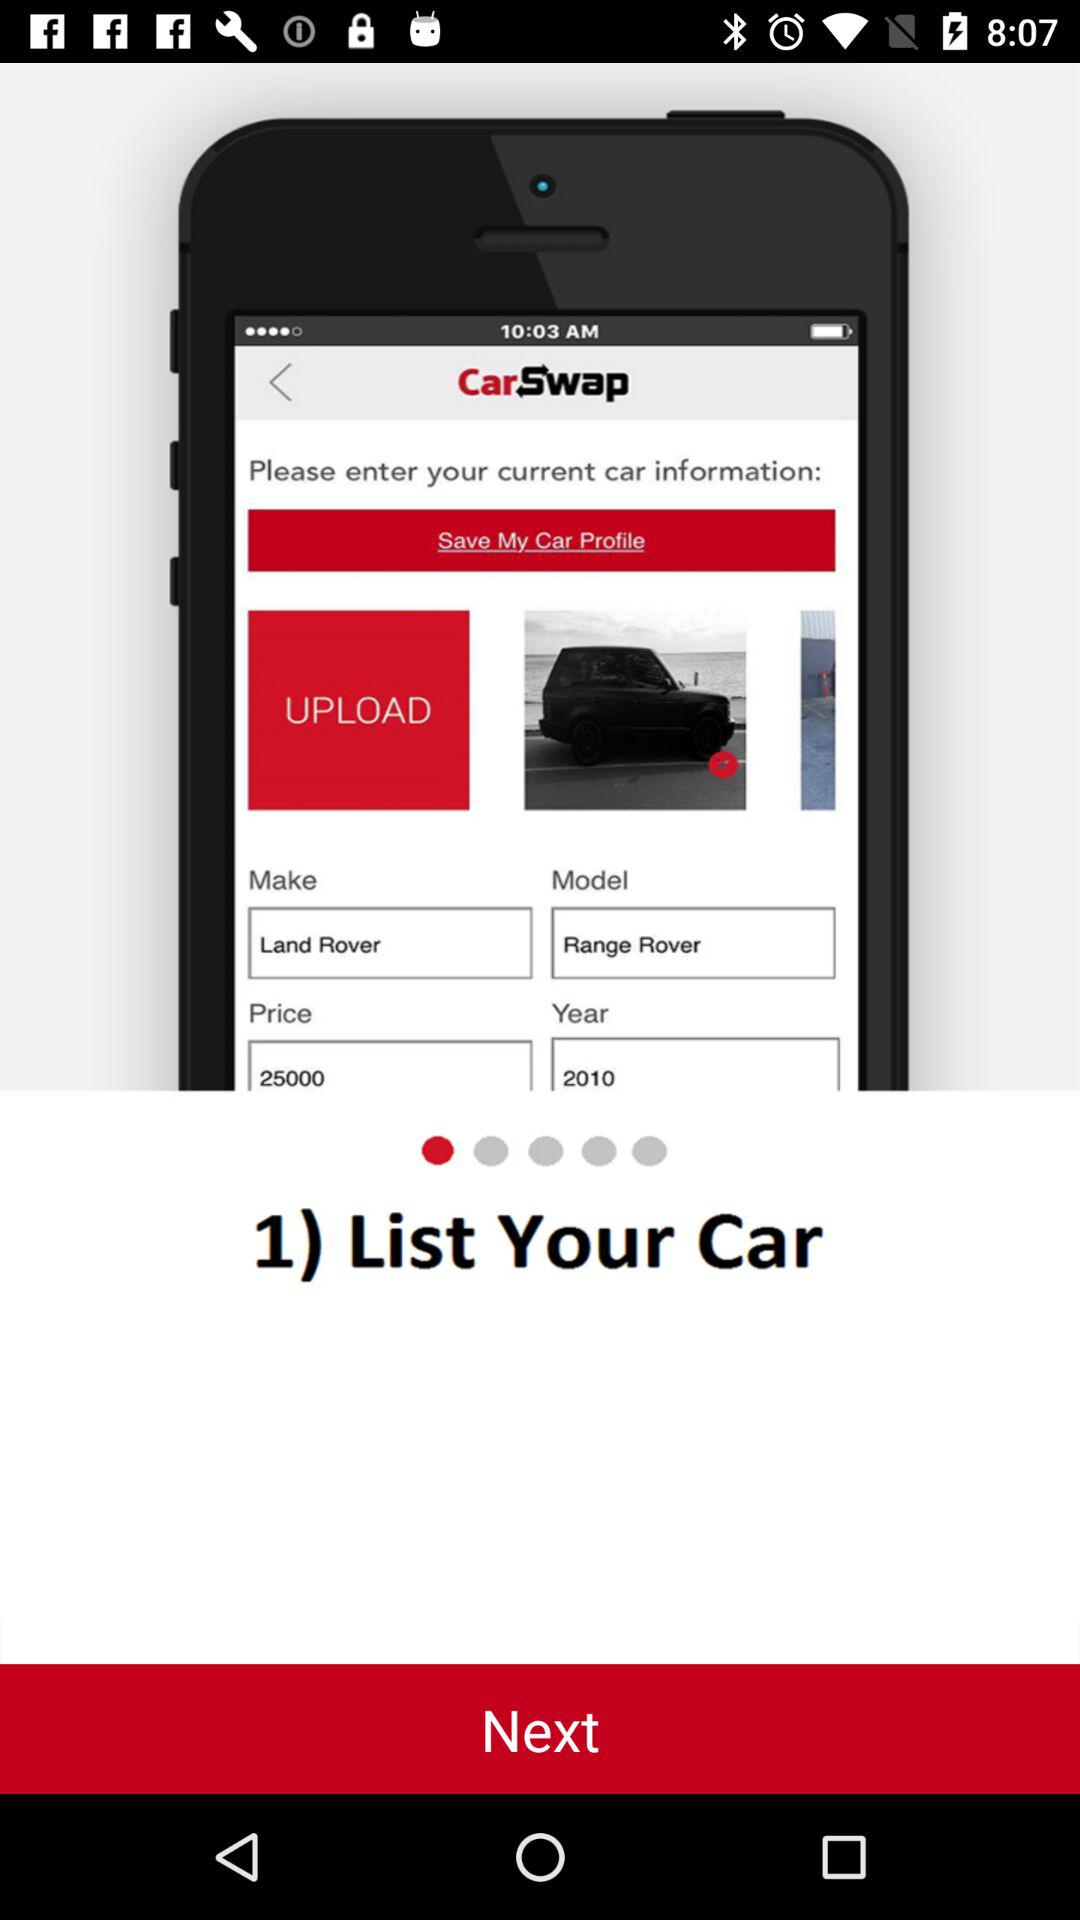What is the year of the Range Rover model? The year of the Range Rover model is 2010. 